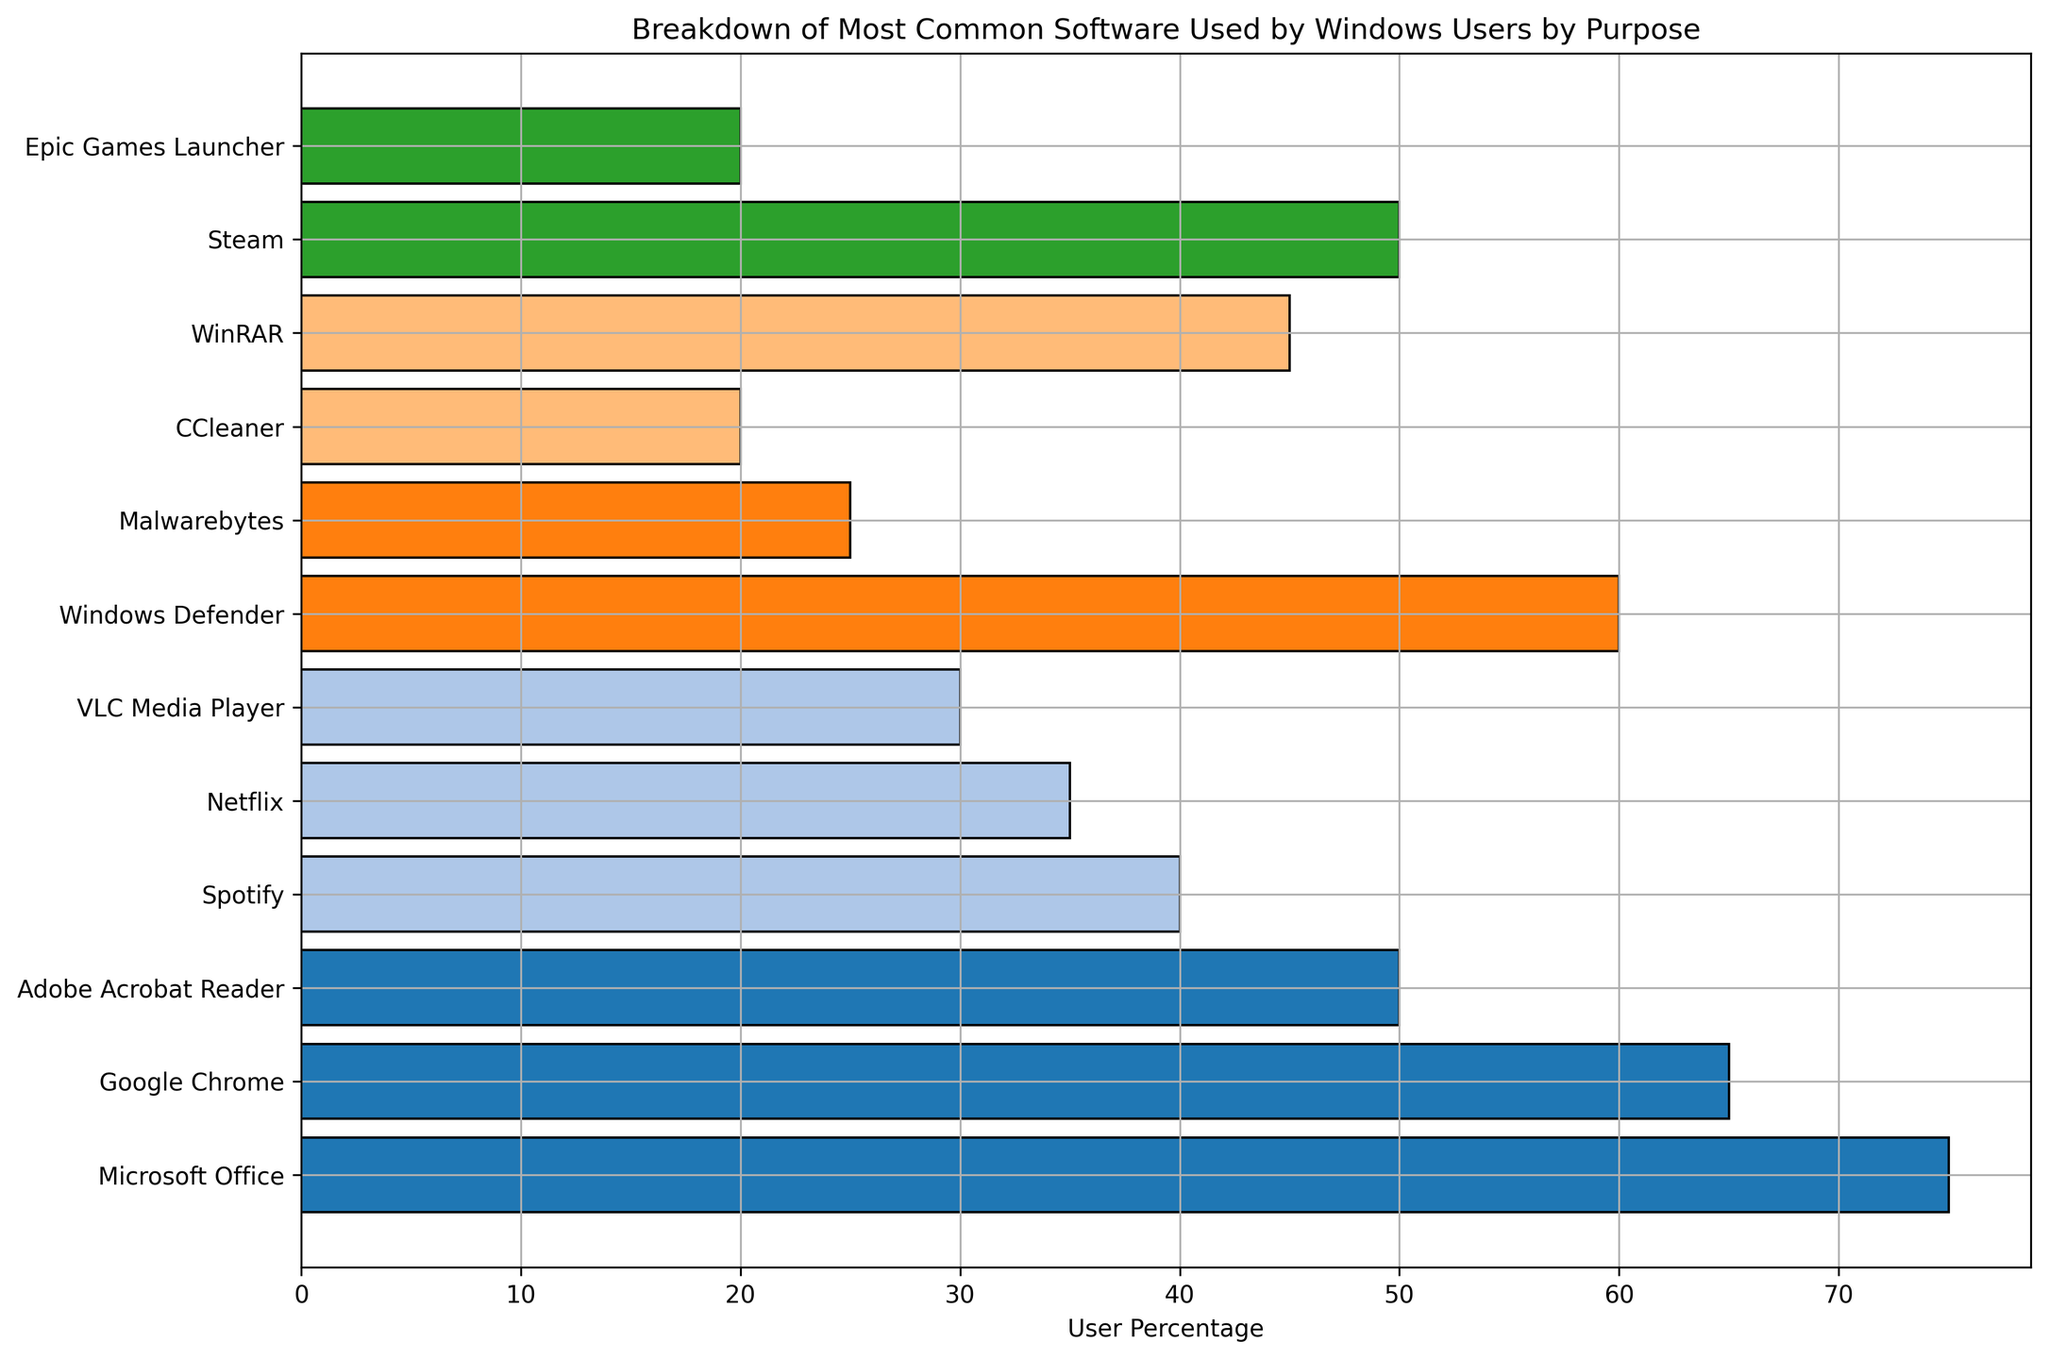Which software is the most commonly used for productivity? From the plot, the tallest bar in the productivity category represents Microsoft Office, indicating it has the highest user percentage in this category.
Answer: Microsoft Office Which category has the software with the highest user percentage? The plot shows that Microsoft Office in the productivity category has the tallest bar overall, making productivity the category with the software having the highest user percentage.
Answer: Productivity Compare the user percentages of Steam and Epic Games Launcher. Which one is more popular? By comparing the lengths of the bars for Steam and Epic Games Launcher, we can see that Steam has a longer bar, indicating a higher user percentage.
Answer: Steam What's the total user percentage for all software in the entertainment category? The user percentages for the entertainment category are: Spotify (40), Netflix (35), VLC Media Player (30). Summing them up gives 40 + 35 + 30 = 105.
Answer: 105 Is Spotify more popular than Google Chrome among Windows users? Comparing the bars, Google Chrome has a longer bar (65%) than Spotify (40%), indicating Google Chrome is more popular.
Answer: No Which software has the highest user percentage in the security category? Among the security software, Windows Defender has the tallest bar, representing the highest user percentage.
Answer: Windows Defender How does the usage of VLC Media Player compare to Malwarebytes? The plot shows that the user percentage for VLC Media Player (30) is higher than that for Malwarebytes (25).
Answer: VLC Media Player Calculate the average user percentage of the gaming software. Gaming category includes Steam (50) and Epic Games Launcher (20). The average is calculated as (50 + 20) / 2 = 35.
Answer: 35 Which software in the utilities category has higher user percentage, CCleaner or WinRAR? In the utilities category, the bar for WinRAR (45) is taller than the bar for CCleaner (20), indicating WinRAR has a higher user percentage.
Answer: WinRAR 